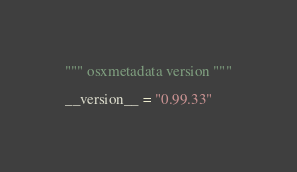Convert code to text. <code><loc_0><loc_0><loc_500><loc_500><_Python_>""" osxmetadata version """

__version__ = "0.99.33"
</code> 